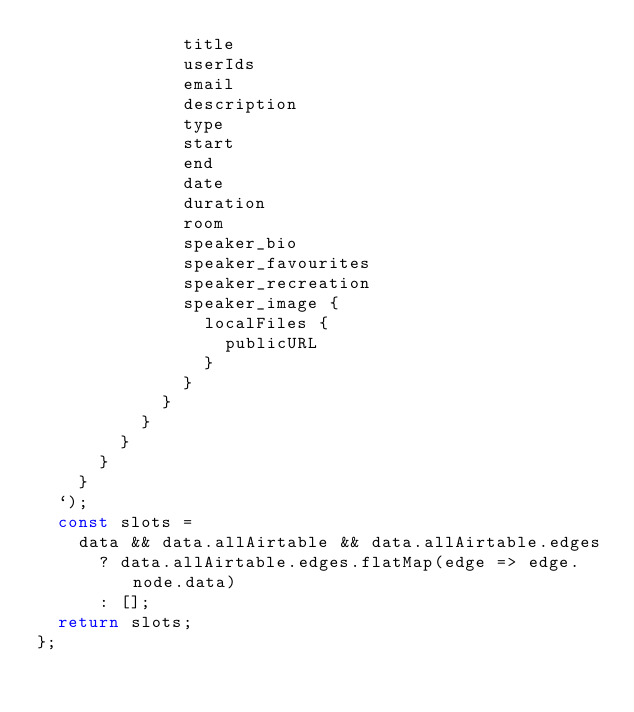<code> <loc_0><loc_0><loc_500><loc_500><_JavaScript_>              title
              userIds
              email
              description
              type
              start
              end
              date
              duration
              room
              speaker_bio
              speaker_favourites
              speaker_recreation
              speaker_image {
                localFiles {
                  publicURL
                }
              }
            }
          }
        }
      }
    }
  `);
  const slots =
    data && data.allAirtable && data.allAirtable.edges
      ? data.allAirtable.edges.flatMap(edge => edge.node.data)
      : [];
  return slots;
};
</code> 